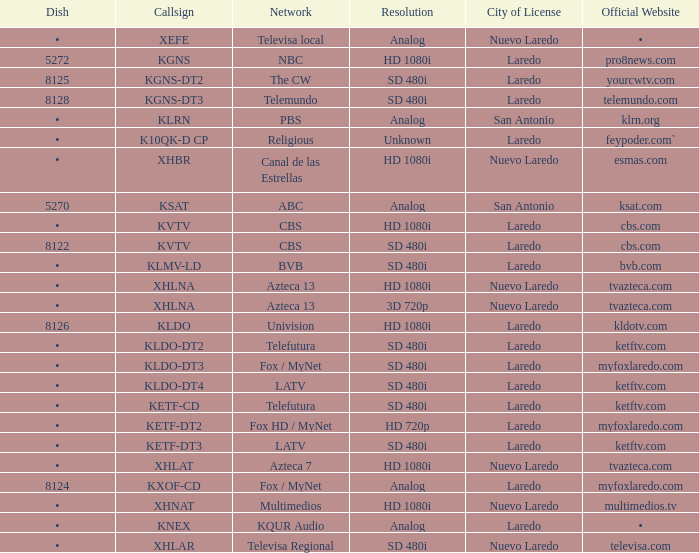Name the official website which has dish of • and callsign of kvtv Cbs.com. 